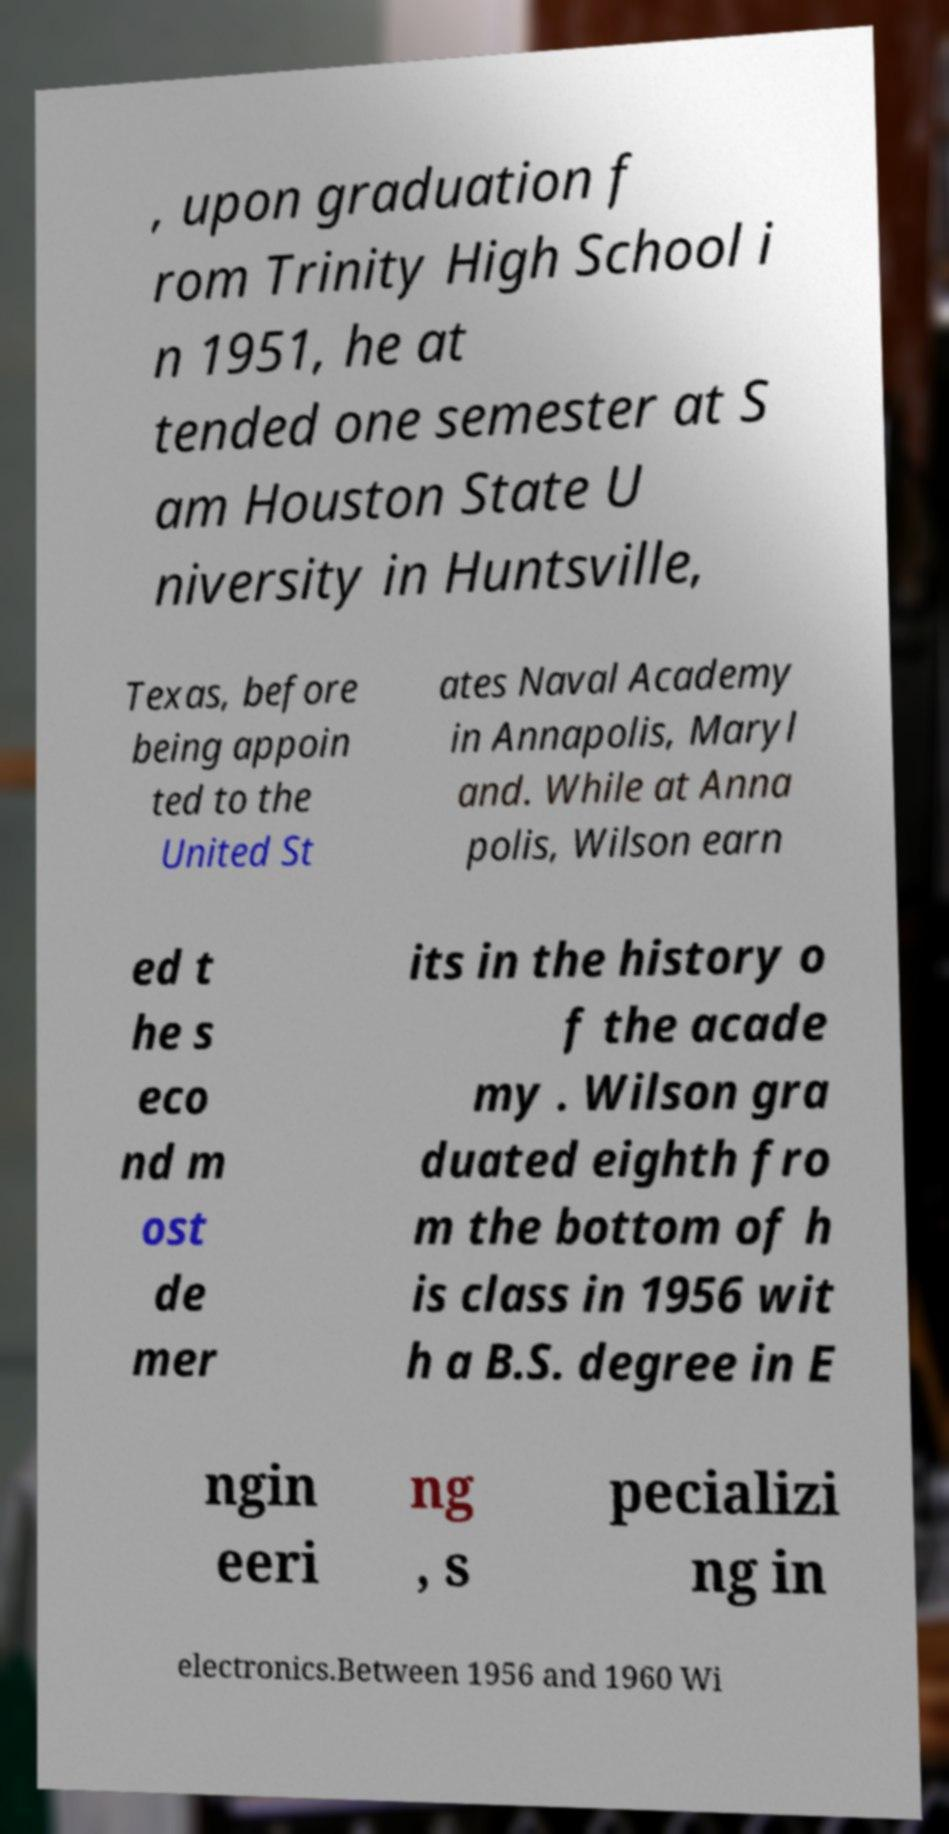Please read and relay the text visible in this image. What does it say? , upon graduation f rom Trinity High School i n 1951, he at tended one semester at S am Houston State U niversity in Huntsville, Texas, before being appoin ted to the United St ates Naval Academy in Annapolis, Maryl and. While at Anna polis, Wilson earn ed t he s eco nd m ost de mer its in the history o f the acade my . Wilson gra duated eighth fro m the bottom of h is class in 1956 wit h a B.S. degree in E ngin eeri ng , s pecializi ng in electronics.Between 1956 and 1960 Wi 